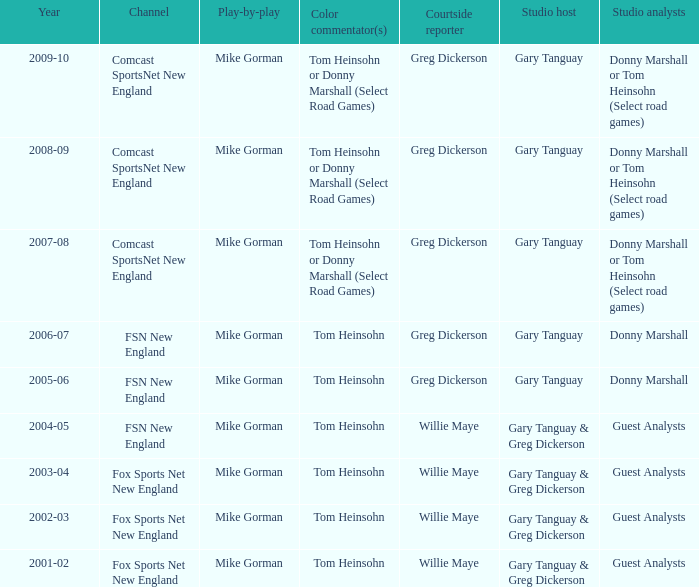Who is the sideline reporter during the 2009-10 season? Greg Dickerson. 